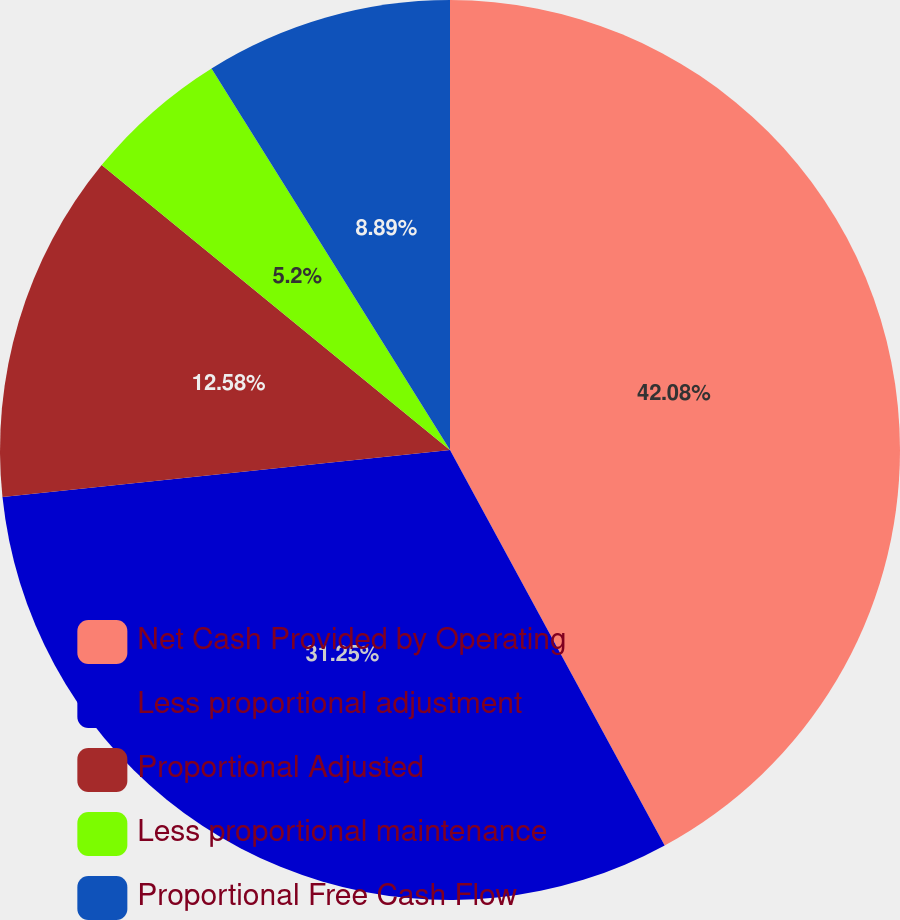<chart> <loc_0><loc_0><loc_500><loc_500><pie_chart><fcel>Net Cash Provided by Operating<fcel>Less proportional adjustment<fcel>Proportional Adjusted<fcel>Less proportional maintenance<fcel>Proportional Free Cash Flow<nl><fcel>42.09%<fcel>31.25%<fcel>12.58%<fcel>5.2%<fcel>8.89%<nl></chart> 